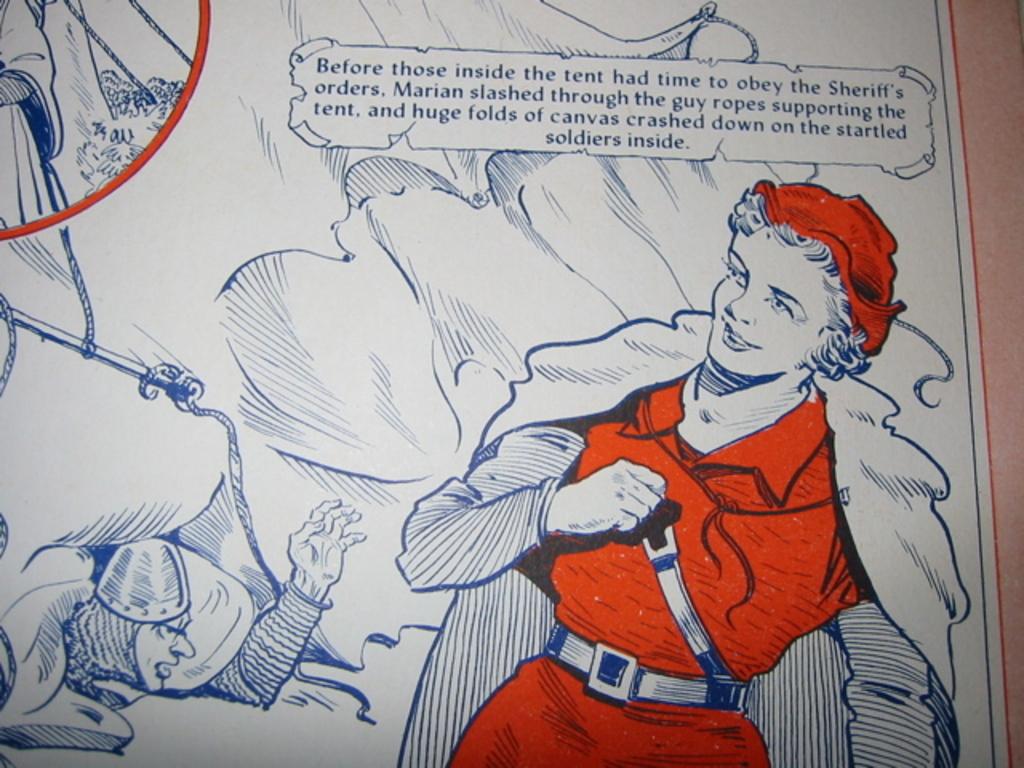Who was inside the tent in the story?
Your response must be concise. Soldiers. What is the last word on the page?
Ensure brevity in your answer.  Inside. 